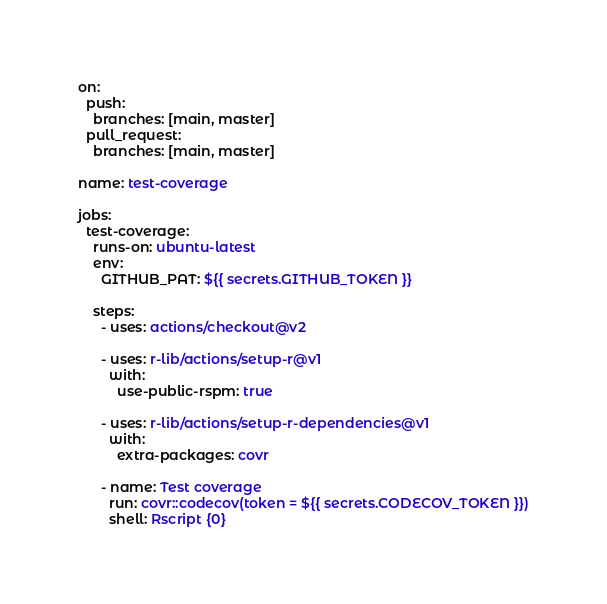Convert code to text. <code><loc_0><loc_0><loc_500><loc_500><_YAML_>on:
  push:
    branches: [main, master]
  pull_request:
    branches: [main, master]

name: test-coverage

jobs:
  test-coverage:
    runs-on: ubuntu-latest
    env:
      GITHUB_PAT: ${{ secrets.GITHUB_TOKEN }}

    steps:
      - uses: actions/checkout@v2

      - uses: r-lib/actions/setup-r@v1
        with:
          use-public-rspm: true

      - uses: r-lib/actions/setup-r-dependencies@v1
        with:
          extra-packages: covr

      - name: Test coverage
        run: covr::codecov(token = ${{ secrets.CODECOV_TOKEN }})
        shell: Rscript {0}
</code> 